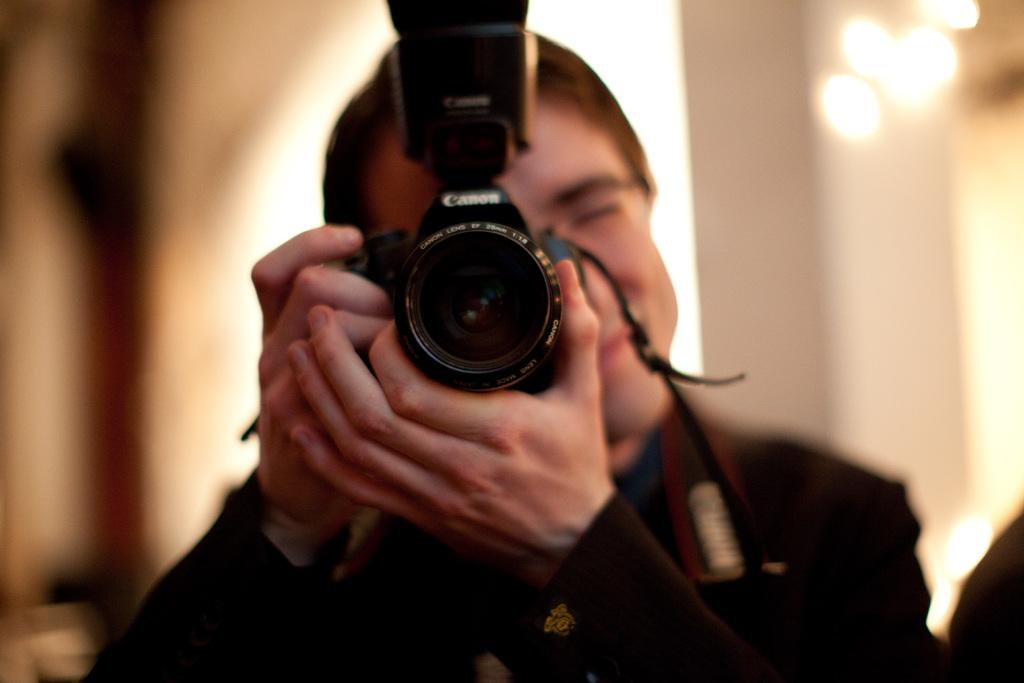Who is the main subject in the image? There is a man in the image. Where is the man located in the image? The man is at the center of the image. What is the man holding in his hands? The man is holding a camera in his hands. What can be seen at the right side of the image? There are lights at the right side of the image. What might the man be doing with the camera? It appears that the man is taking a photo. What type of nerve is visible in the image? There is no nerve visible in the image; it features a man holding a camera and lights at the right side. 